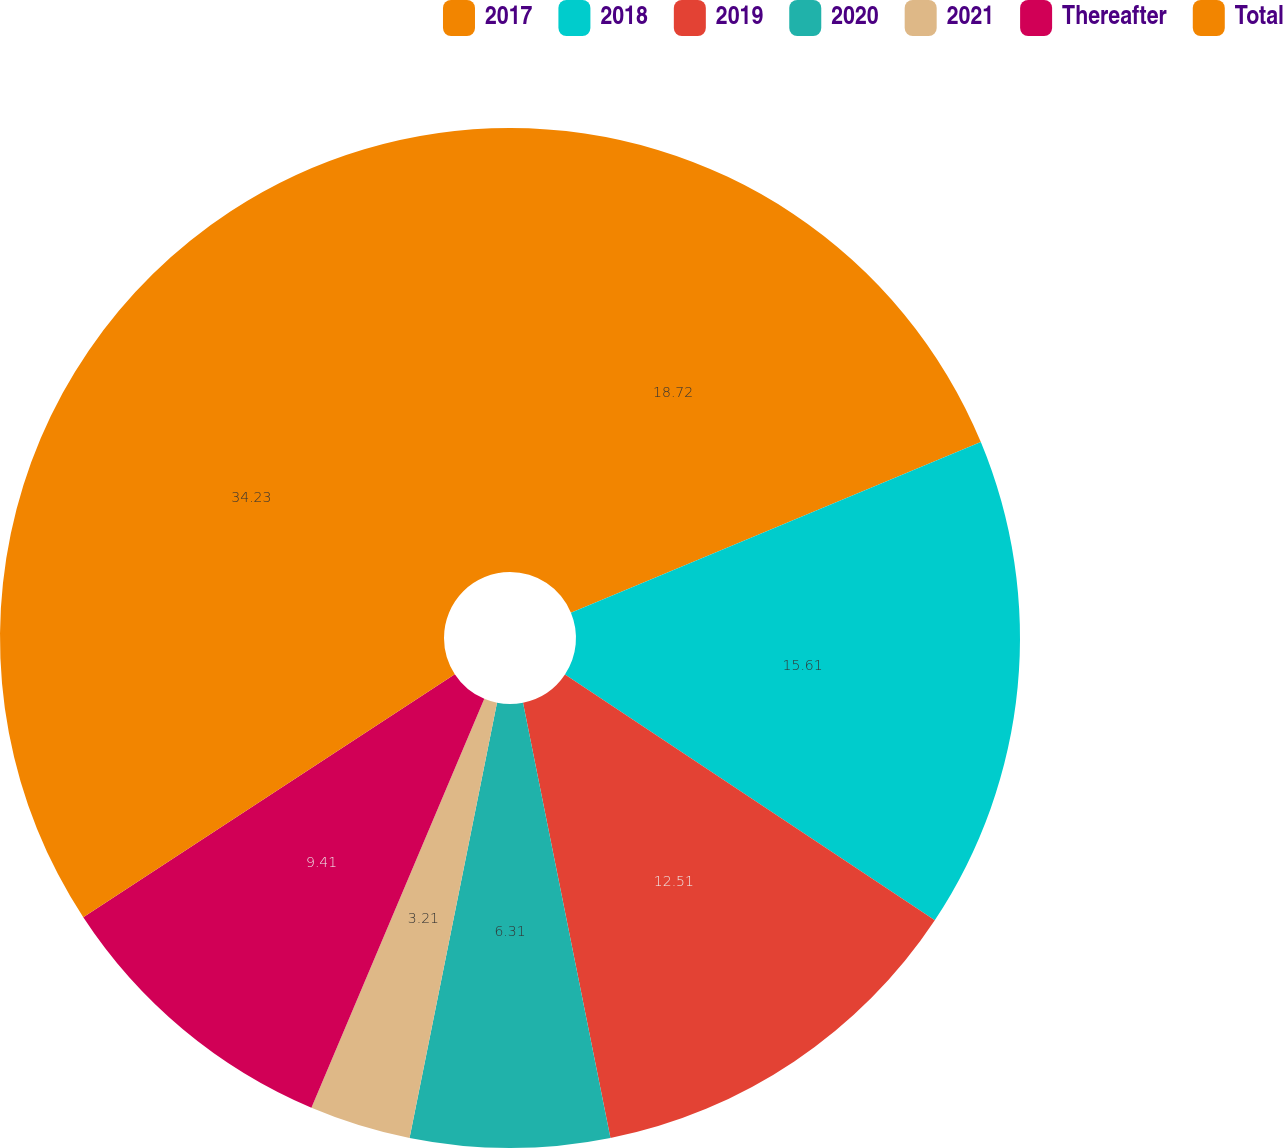Convert chart. <chart><loc_0><loc_0><loc_500><loc_500><pie_chart><fcel>2017<fcel>2018<fcel>2019<fcel>2020<fcel>2021<fcel>Thereafter<fcel>Total<nl><fcel>18.72%<fcel>15.61%<fcel>12.51%<fcel>6.31%<fcel>3.21%<fcel>9.41%<fcel>34.22%<nl></chart> 